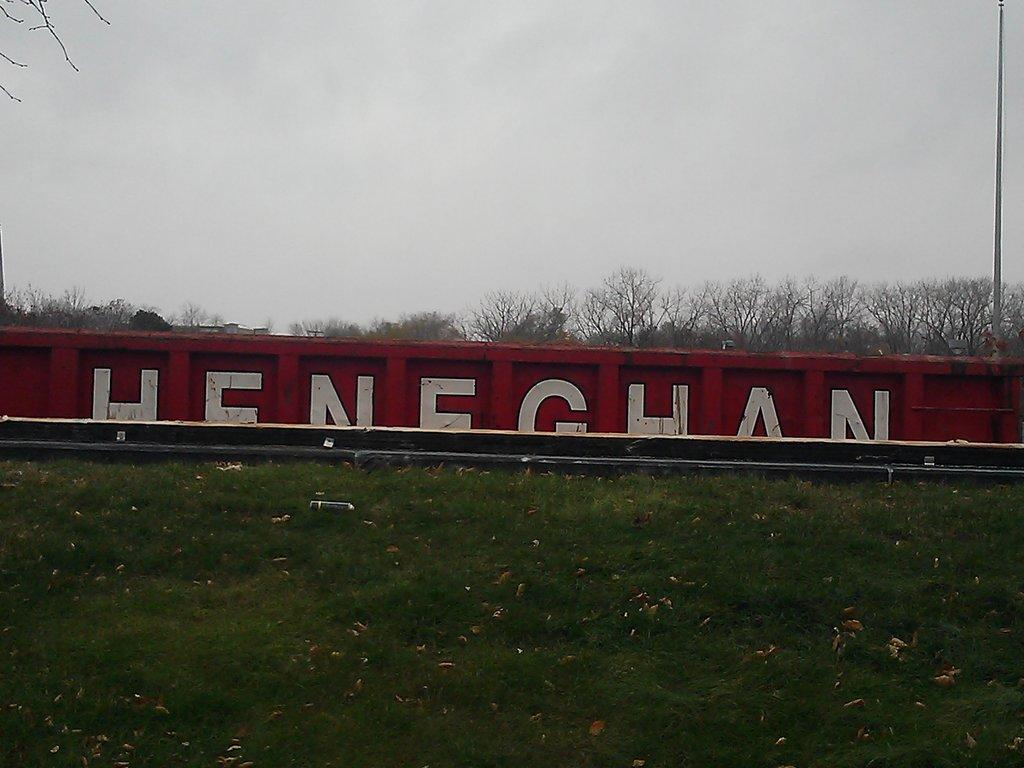<image>
Summarize the visual content of the image. A train car that says Heneghan is shown behind some grass. 